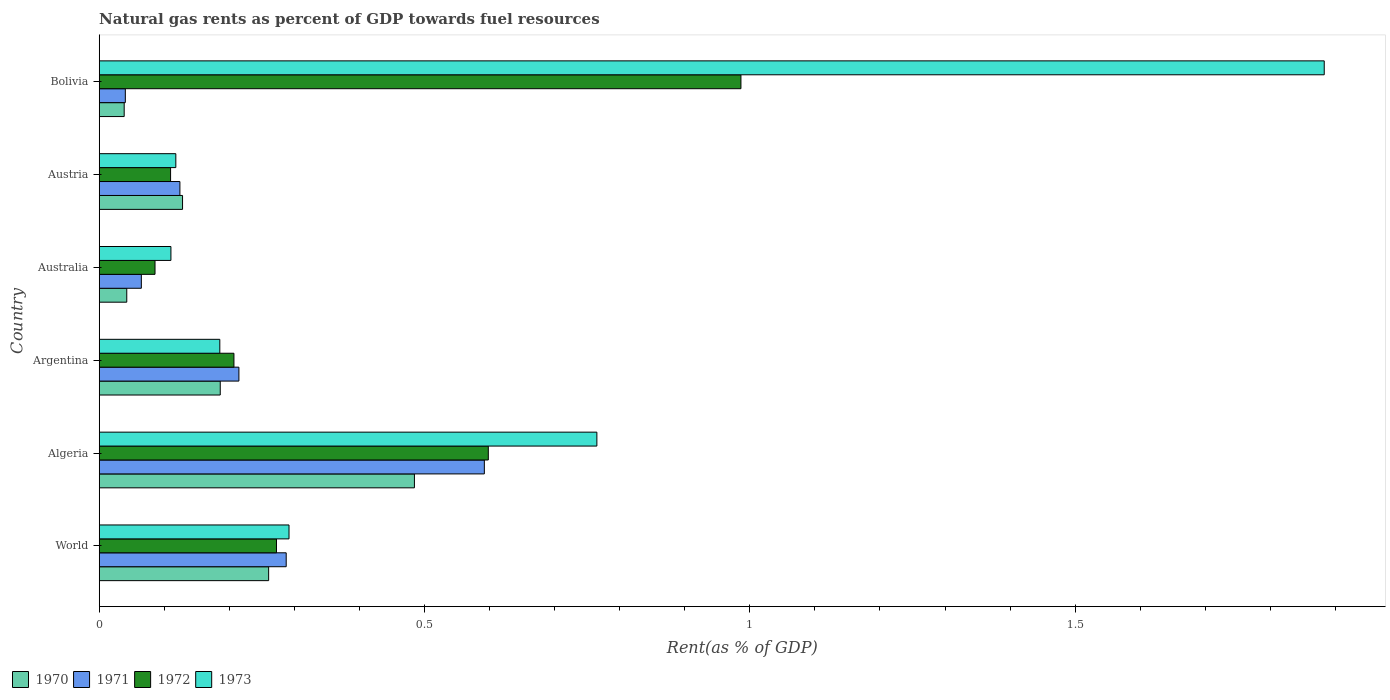Are the number of bars on each tick of the Y-axis equal?
Offer a very short reply. Yes. What is the label of the 4th group of bars from the top?
Offer a terse response. Argentina. In how many cases, is the number of bars for a given country not equal to the number of legend labels?
Make the answer very short. 0. What is the matural gas rent in 1971 in World?
Ensure brevity in your answer.  0.29. Across all countries, what is the maximum matural gas rent in 1970?
Keep it short and to the point. 0.48. Across all countries, what is the minimum matural gas rent in 1971?
Ensure brevity in your answer.  0.04. What is the total matural gas rent in 1970 in the graph?
Your answer should be very brief. 1.14. What is the difference between the matural gas rent in 1972 in Argentina and that in Austria?
Your response must be concise. 0.1. What is the difference between the matural gas rent in 1970 in Australia and the matural gas rent in 1973 in Austria?
Ensure brevity in your answer.  -0.08. What is the average matural gas rent in 1971 per country?
Keep it short and to the point. 0.22. What is the difference between the matural gas rent in 1971 and matural gas rent in 1970 in World?
Give a very brief answer. 0.03. In how many countries, is the matural gas rent in 1972 greater than 0.9 %?
Give a very brief answer. 1. What is the ratio of the matural gas rent in 1972 in Argentina to that in Bolivia?
Offer a very short reply. 0.21. Is the matural gas rent in 1970 in Argentina less than that in Austria?
Provide a succinct answer. No. What is the difference between the highest and the second highest matural gas rent in 1970?
Provide a short and direct response. 0.22. What is the difference between the highest and the lowest matural gas rent in 1971?
Provide a short and direct response. 0.55. In how many countries, is the matural gas rent in 1971 greater than the average matural gas rent in 1971 taken over all countries?
Your answer should be very brief. 2. Is the sum of the matural gas rent in 1970 in Algeria and Bolivia greater than the maximum matural gas rent in 1972 across all countries?
Offer a terse response. No. Is it the case that in every country, the sum of the matural gas rent in 1973 and matural gas rent in 1971 is greater than the sum of matural gas rent in 1972 and matural gas rent in 1970?
Provide a succinct answer. No. What does the 3rd bar from the top in World represents?
Provide a short and direct response. 1971. What does the 4th bar from the bottom in World represents?
Offer a terse response. 1973. Is it the case that in every country, the sum of the matural gas rent in 1971 and matural gas rent in 1973 is greater than the matural gas rent in 1970?
Your response must be concise. Yes. How many bars are there?
Offer a terse response. 24. What is the difference between two consecutive major ticks on the X-axis?
Offer a terse response. 0.5. Does the graph contain grids?
Ensure brevity in your answer.  No. How are the legend labels stacked?
Your response must be concise. Horizontal. What is the title of the graph?
Ensure brevity in your answer.  Natural gas rents as percent of GDP towards fuel resources. Does "1966" appear as one of the legend labels in the graph?
Your answer should be compact. No. What is the label or title of the X-axis?
Your answer should be compact. Rent(as % of GDP). What is the Rent(as % of GDP) in 1970 in World?
Ensure brevity in your answer.  0.26. What is the Rent(as % of GDP) in 1971 in World?
Provide a short and direct response. 0.29. What is the Rent(as % of GDP) in 1972 in World?
Make the answer very short. 0.27. What is the Rent(as % of GDP) in 1973 in World?
Keep it short and to the point. 0.29. What is the Rent(as % of GDP) of 1970 in Algeria?
Your answer should be compact. 0.48. What is the Rent(as % of GDP) in 1971 in Algeria?
Provide a succinct answer. 0.59. What is the Rent(as % of GDP) in 1972 in Algeria?
Keep it short and to the point. 0.6. What is the Rent(as % of GDP) in 1973 in Algeria?
Your answer should be compact. 0.76. What is the Rent(as % of GDP) in 1970 in Argentina?
Ensure brevity in your answer.  0.19. What is the Rent(as % of GDP) of 1971 in Argentina?
Give a very brief answer. 0.21. What is the Rent(as % of GDP) in 1972 in Argentina?
Make the answer very short. 0.21. What is the Rent(as % of GDP) in 1973 in Argentina?
Provide a short and direct response. 0.19. What is the Rent(as % of GDP) in 1970 in Australia?
Your response must be concise. 0.04. What is the Rent(as % of GDP) in 1971 in Australia?
Offer a terse response. 0.06. What is the Rent(as % of GDP) in 1972 in Australia?
Provide a succinct answer. 0.09. What is the Rent(as % of GDP) in 1973 in Australia?
Offer a terse response. 0.11. What is the Rent(as % of GDP) of 1970 in Austria?
Offer a very short reply. 0.13. What is the Rent(as % of GDP) in 1971 in Austria?
Provide a short and direct response. 0.12. What is the Rent(as % of GDP) of 1972 in Austria?
Make the answer very short. 0.11. What is the Rent(as % of GDP) of 1973 in Austria?
Your answer should be compact. 0.12. What is the Rent(as % of GDP) of 1970 in Bolivia?
Keep it short and to the point. 0.04. What is the Rent(as % of GDP) of 1971 in Bolivia?
Your answer should be very brief. 0.04. What is the Rent(as % of GDP) in 1972 in Bolivia?
Offer a very short reply. 0.99. What is the Rent(as % of GDP) in 1973 in Bolivia?
Offer a terse response. 1.88. Across all countries, what is the maximum Rent(as % of GDP) of 1970?
Your response must be concise. 0.48. Across all countries, what is the maximum Rent(as % of GDP) of 1971?
Your answer should be very brief. 0.59. Across all countries, what is the maximum Rent(as % of GDP) of 1972?
Your answer should be compact. 0.99. Across all countries, what is the maximum Rent(as % of GDP) in 1973?
Your answer should be compact. 1.88. Across all countries, what is the minimum Rent(as % of GDP) of 1970?
Offer a terse response. 0.04. Across all countries, what is the minimum Rent(as % of GDP) of 1971?
Give a very brief answer. 0.04. Across all countries, what is the minimum Rent(as % of GDP) of 1972?
Your response must be concise. 0.09. Across all countries, what is the minimum Rent(as % of GDP) in 1973?
Keep it short and to the point. 0.11. What is the total Rent(as % of GDP) of 1970 in the graph?
Your response must be concise. 1.14. What is the total Rent(as % of GDP) in 1971 in the graph?
Offer a terse response. 1.32. What is the total Rent(as % of GDP) of 1972 in the graph?
Offer a very short reply. 2.26. What is the total Rent(as % of GDP) of 1973 in the graph?
Make the answer very short. 3.35. What is the difference between the Rent(as % of GDP) in 1970 in World and that in Algeria?
Your response must be concise. -0.22. What is the difference between the Rent(as % of GDP) in 1971 in World and that in Algeria?
Your answer should be compact. -0.3. What is the difference between the Rent(as % of GDP) of 1972 in World and that in Algeria?
Give a very brief answer. -0.33. What is the difference between the Rent(as % of GDP) in 1973 in World and that in Algeria?
Keep it short and to the point. -0.47. What is the difference between the Rent(as % of GDP) of 1970 in World and that in Argentina?
Your response must be concise. 0.07. What is the difference between the Rent(as % of GDP) of 1971 in World and that in Argentina?
Offer a terse response. 0.07. What is the difference between the Rent(as % of GDP) of 1972 in World and that in Argentina?
Give a very brief answer. 0.07. What is the difference between the Rent(as % of GDP) of 1973 in World and that in Argentina?
Offer a terse response. 0.11. What is the difference between the Rent(as % of GDP) in 1970 in World and that in Australia?
Provide a short and direct response. 0.22. What is the difference between the Rent(as % of GDP) in 1971 in World and that in Australia?
Your answer should be compact. 0.22. What is the difference between the Rent(as % of GDP) of 1972 in World and that in Australia?
Your answer should be very brief. 0.19. What is the difference between the Rent(as % of GDP) of 1973 in World and that in Australia?
Your answer should be compact. 0.18. What is the difference between the Rent(as % of GDP) in 1970 in World and that in Austria?
Your answer should be compact. 0.13. What is the difference between the Rent(as % of GDP) in 1971 in World and that in Austria?
Your response must be concise. 0.16. What is the difference between the Rent(as % of GDP) of 1972 in World and that in Austria?
Offer a terse response. 0.16. What is the difference between the Rent(as % of GDP) of 1973 in World and that in Austria?
Provide a short and direct response. 0.17. What is the difference between the Rent(as % of GDP) of 1970 in World and that in Bolivia?
Your answer should be very brief. 0.22. What is the difference between the Rent(as % of GDP) in 1971 in World and that in Bolivia?
Provide a succinct answer. 0.25. What is the difference between the Rent(as % of GDP) in 1972 in World and that in Bolivia?
Provide a succinct answer. -0.71. What is the difference between the Rent(as % of GDP) of 1973 in World and that in Bolivia?
Give a very brief answer. -1.59. What is the difference between the Rent(as % of GDP) in 1970 in Algeria and that in Argentina?
Your response must be concise. 0.3. What is the difference between the Rent(as % of GDP) of 1971 in Algeria and that in Argentina?
Give a very brief answer. 0.38. What is the difference between the Rent(as % of GDP) in 1972 in Algeria and that in Argentina?
Give a very brief answer. 0.39. What is the difference between the Rent(as % of GDP) of 1973 in Algeria and that in Argentina?
Make the answer very short. 0.58. What is the difference between the Rent(as % of GDP) of 1970 in Algeria and that in Australia?
Make the answer very short. 0.44. What is the difference between the Rent(as % of GDP) of 1971 in Algeria and that in Australia?
Give a very brief answer. 0.53. What is the difference between the Rent(as % of GDP) of 1972 in Algeria and that in Australia?
Ensure brevity in your answer.  0.51. What is the difference between the Rent(as % of GDP) in 1973 in Algeria and that in Australia?
Offer a very short reply. 0.65. What is the difference between the Rent(as % of GDP) in 1970 in Algeria and that in Austria?
Provide a short and direct response. 0.36. What is the difference between the Rent(as % of GDP) in 1971 in Algeria and that in Austria?
Ensure brevity in your answer.  0.47. What is the difference between the Rent(as % of GDP) in 1972 in Algeria and that in Austria?
Make the answer very short. 0.49. What is the difference between the Rent(as % of GDP) of 1973 in Algeria and that in Austria?
Give a very brief answer. 0.65. What is the difference between the Rent(as % of GDP) of 1970 in Algeria and that in Bolivia?
Ensure brevity in your answer.  0.45. What is the difference between the Rent(as % of GDP) of 1971 in Algeria and that in Bolivia?
Your answer should be very brief. 0.55. What is the difference between the Rent(as % of GDP) in 1972 in Algeria and that in Bolivia?
Keep it short and to the point. -0.39. What is the difference between the Rent(as % of GDP) of 1973 in Algeria and that in Bolivia?
Provide a succinct answer. -1.12. What is the difference between the Rent(as % of GDP) in 1970 in Argentina and that in Australia?
Your answer should be compact. 0.14. What is the difference between the Rent(as % of GDP) of 1971 in Argentina and that in Australia?
Your answer should be compact. 0.15. What is the difference between the Rent(as % of GDP) of 1972 in Argentina and that in Australia?
Provide a short and direct response. 0.12. What is the difference between the Rent(as % of GDP) of 1973 in Argentina and that in Australia?
Offer a very short reply. 0.08. What is the difference between the Rent(as % of GDP) in 1970 in Argentina and that in Austria?
Provide a short and direct response. 0.06. What is the difference between the Rent(as % of GDP) in 1971 in Argentina and that in Austria?
Your answer should be very brief. 0.09. What is the difference between the Rent(as % of GDP) of 1972 in Argentina and that in Austria?
Offer a terse response. 0.1. What is the difference between the Rent(as % of GDP) of 1973 in Argentina and that in Austria?
Offer a terse response. 0.07. What is the difference between the Rent(as % of GDP) in 1970 in Argentina and that in Bolivia?
Offer a terse response. 0.15. What is the difference between the Rent(as % of GDP) in 1971 in Argentina and that in Bolivia?
Ensure brevity in your answer.  0.17. What is the difference between the Rent(as % of GDP) of 1972 in Argentina and that in Bolivia?
Give a very brief answer. -0.78. What is the difference between the Rent(as % of GDP) of 1973 in Argentina and that in Bolivia?
Offer a terse response. -1.7. What is the difference between the Rent(as % of GDP) of 1970 in Australia and that in Austria?
Your answer should be very brief. -0.09. What is the difference between the Rent(as % of GDP) in 1971 in Australia and that in Austria?
Keep it short and to the point. -0.06. What is the difference between the Rent(as % of GDP) in 1972 in Australia and that in Austria?
Keep it short and to the point. -0.02. What is the difference between the Rent(as % of GDP) in 1973 in Australia and that in Austria?
Keep it short and to the point. -0.01. What is the difference between the Rent(as % of GDP) in 1970 in Australia and that in Bolivia?
Offer a terse response. 0. What is the difference between the Rent(as % of GDP) in 1971 in Australia and that in Bolivia?
Provide a short and direct response. 0.02. What is the difference between the Rent(as % of GDP) of 1972 in Australia and that in Bolivia?
Your answer should be very brief. -0.9. What is the difference between the Rent(as % of GDP) of 1973 in Australia and that in Bolivia?
Your response must be concise. -1.77. What is the difference between the Rent(as % of GDP) of 1970 in Austria and that in Bolivia?
Your answer should be compact. 0.09. What is the difference between the Rent(as % of GDP) in 1971 in Austria and that in Bolivia?
Your response must be concise. 0.08. What is the difference between the Rent(as % of GDP) in 1972 in Austria and that in Bolivia?
Offer a terse response. -0.88. What is the difference between the Rent(as % of GDP) in 1973 in Austria and that in Bolivia?
Keep it short and to the point. -1.77. What is the difference between the Rent(as % of GDP) of 1970 in World and the Rent(as % of GDP) of 1971 in Algeria?
Provide a short and direct response. -0.33. What is the difference between the Rent(as % of GDP) in 1970 in World and the Rent(as % of GDP) in 1972 in Algeria?
Offer a very short reply. -0.34. What is the difference between the Rent(as % of GDP) in 1970 in World and the Rent(as % of GDP) in 1973 in Algeria?
Keep it short and to the point. -0.5. What is the difference between the Rent(as % of GDP) in 1971 in World and the Rent(as % of GDP) in 1972 in Algeria?
Provide a short and direct response. -0.31. What is the difference between the Rent(as % of GDP) of 1971 in World and the Rent(as % of GDP) of 1973 in Algeria?
Provide a short and direct response. -0.48. What is the difference between the Rent(as % of GDP) in 1972 in World and the Rent(as % of GDP) in 1973 in Algeria?
Your answer should be very brief. -0.49. What is the difference between the Rent(as % of GDP) in 1970 in World and the Rent(as % of GDP) in 1971 in Argentina?
Your answer should be compact. 0.05. What is the difference between the Rent(as % of GDP) of 1970 in World and the Rent(as % of GDP) of 1972 in Argentina?
Keep it short and to the point. 0.05. What is the difference between the Rent(as % of GDP) in 1970 in World and the Rent(as % of GDP) in 1973 in Argentina?
Your answer should be compact. 0.07. What is the difference between the Rent(as % of GDP) in 1971 in World and the Rent(as % of GDP) in 1972 in Argentina?
Your answer should be compact. 0.08. What is the difference between the Rent(as % of GDP) in 1971 in World and the Rent(as % of GDP) in 1973 in Argentina?
Provide a succinct answer. 0.1. What is the difference between the Rent(as % of GDP) of 1972 in World and the Rent(as % of GDP) of 1973 in Argentina?
Your response must be concise. 0.09. What is the difference between the Rent(as % of GDP) in 1970 in World and the Rent(as % of GDP) in 1971 in Australia?
Give a very brief answer. 0.2. What is the difference between the Rent(as % of GDP) in 1970 in World and the Rent(as % of GDP) in 1972 in Australia?
Provide a succinct answer. 0.17. What is the difference between the Rent(as % of GDP) in 1970 in World and the Rent(as % of GDP) in 1973 in Australia?
Your answer should be compact. 0.15. What is the difference between the Rent(as % of GDP) of 1971 in World and the Rent(as % of GDP) of 1972 in Australia?
Provide a succinct answer. 0.2. What is the difference between the Rent(as % of GDP) in 1971 in World and the Rent(as % of GDP) in 1973 in Australia?
Offer a terse response. 0.18. What is the difference between the Rent(as % of GDP) of 1972 in World and the Rent(as % of GDP) of 1973 in Australia?
Give a very brief answer. 0.16. What is the difference between the Rent(as % of GDP) of 1970 in World and the Rent(as % of GDP) of 1971 in Austria?
Your answer should be very brief. 0.14. What is the difference between the Rent(as % of GDP) in 1970 in World and the Rent(as % of GDP) in 1972 in Austria?
Make the answer very short. 0.15. What is the difference between the Rent(as % of GDP) of 1970 in World and the Rent(as % of GDP) of 1973 in Austria?
Offer a terse response. 0.14. What is the difference between the Rent(as % of GDP) in 1971 in World and the Rent(as % of GDP) in 1972 in Austria?
Keep it short and to the point. 0.18. What is the difference between the Rent(as % of GDP) of 1971 in World and the Rent(as % of GDP) of 1973 in Austria?
Ensure brevity in your answer.  0.17. What is the difference between the Rent(as % of GDP) of 1972 in World and the Rent(as % of GDP) of 1973 in Austria?
Keep it short and to the point. 0.15. What is the difference between the Rent(as % of GDP) of 1970 in World and the Rent(as % of GDP) of 1971 in Bolivia?
Your answer should be compact. 0.22. What is the difference between the Rent(as % of GDP) in 1970 in World and the Rent(as % of GDP) in 1972 in Bolivia?
Offer a terse response. -0.73. What is the difference between the Rent(as % of GDP) in 1970 in World and the Rent(as % of GDP) in 1973 in Bolivia?
Your response must be concise. -1.62. What is the difference between the Rent(as % of GDP) of 1971 in World and the Rent(as % of GDP) of 1972 in Bolivia?
Keep it short and to the point. -0.7. What is the difference between the Rent(as % of GDP) of 1971 in World and the Rent(as % of GDP) of 1973 in Bolivia?
Keep it short and to the point. -1.6. What is the difference between the Rent(as % of GDP) of 1972 in World and the Rent(as % of GDP) of 1973 in Bolivia?
Keep it short and to the point. -1.61. What is the difference between the Rent(as % of GDP) in 1970 in Algeria and the Rent(as % of GDP) in 1971 in Argentina?
Give a very brief answer. 0.27. What is the difference between the Rent(as % of GDP) in 1970 in Algeria and the Rent(as % of GDP) in 1972 in Argentina?
Make the answer very short. 0.28. What is the difference between the Rent(as % of GDP) of 1970 in Algeria and the Rent(as % of GDP) of 1973 in Argentina?
Your answer should be compact. 0.3. What is the difference between the Rent(as % of GDP) of 1971 in Algeria and the Rent(as % of GDP) of 1972 in Argentina?
Make the answer very short. 0.38. What is the difference between the Rent(as % of GDP) of 1971 in Algeria and the Rent(as % of GDP) of 1973 in Argentina?
Make the answer very short. 0.41. What is the difference between the Rent(as % of GDP) of 1972 in Algeria and the Rent(as % of GDP) of 1973 in Argentina?
Offer a terse response. 0.41. What is the difference between the Rent(as % of GDP) of 1970 in Algeria and the Rent(as % of GDP) of 1971 in Australia?
Give a very brief answer. 0.42. What is the difference between the Rent(as % of GDP) in 1970 in Algeria and the Rent(as % of GDP) in 1972 in Australia?
Offer a very short reply. 0.4. What is the difference between the Rent(as % of GDP) in 1970 in Algeria and the Rent(as % of GDP) in 1973 in Australia?
Keep it short and to the point. 0.37. What is the difference between the Rent(as % of GDP) of 1971 in Algeria and the Rent(as % of GDP) of 1972 in Australia?
Offer a terse response. 0.51. What is the difference between the Rent(as % of GDP) in 1971 in Algeria and the Rent(as % of GDP) in 1973 in Australia?
Your answer should be very brief. 0.48. What is the difference between the Rent(as % of GDP) of 1972 in Algeria and the Rent(as % of GDP) of 1973 in Australia?
Keep it short and to the point. 0.49. What is the difference between the Rent(as % of GDP) in 1970 in Algeria and the Rent(as % of GDP) in 1971 in Austria?
Ensure brevity in your answer.  0.36. What is the difference between the Rent(as % of GDP) in 1970 in Algeria and the Rent(as % of GDP) in 1972 in Austria?
Ensure brevity in your answer.  0.37. What is the difference between the Rent(as % of GDP) of 1970 in Algeria and the Rent(as % of GDP) of 1973 in Austria?
Offer a very short reply. 0.37. What is the difference between the Rent(as % of GDP) in 1971 in Algeria and the Rent(as % of GDP) in 1972 in Austria?
Give a very brief answer. 0.48. What is the difference between the Rent(as % of GDP) in 1971 in Algeria and the Rent(as % of GDP) in 1973 in Austria?
Offer a terse response. 0.47. What is the difference between the Rent(as % of GDP) in 1972 in Algeria and the Rent(as % of GDP) in 1973 in Austria?
Your answer should be very brief. 0.48. What is the difference between the Rent(as % of GDP) of 1970 in Algeria and the Rent(as % of GDP) of 1971 in Bolivia?
Offer a very short reply. 0.44. What is the difference between the Rent(as % of GDP) of 1970 in Algeria and the Rent(as % of GDP) of 1972 in Bolivia?
Give a very brief answer. -0.5. What is the difference between the Rent(as % of GDP) of 1970 in Algeria and the Rent(as % of GDP) of 1973 in Bolivia?
Your answer should be very brief. -1.4. What is the difference between the Rent(as % of GDP) in 1971 in Algeria and the Rent(as % of GDP) in 1972 in Bolivia?
Keep it short and to the point. -0.39. What is the difference between the Rent(as % of GDP) of 1971 in Algeria and the Rent(as % of GDP) of 1973 in Bolivia?
Make the answer very short. -1.29. What is the difference between the Rent(as % of GDP) in 1972 in Algeria and the Rent(as % of GDP) in 1973 in Bolivia?
Provide a succinct answer. -1.28. What is the difference between the Rent(as % of GDP) in 1970 in Argentina and the Rent(as % of GDP) in 1971 in Australia?
Ensure brevity in your answer.  0.12. What is the difference between the Rent(as % of GDP) in 1970 in Argentina and the Rent(as % of GDP) in 1972 in Australia?
Your answer should be very brief. 0.1. What is the difference between the Rent(as % of GDP) in 1970 in Argentina and the Rent(as % of GDP) in 1973 in Australia?
Offer a terse response. 0.08. What is the difference between the Rent(as % of GDP) of 1971 in Argentina and the Rent(as % of GDP) of 1972 in Australia?
Your answer should be compact. 0.13. What is the difference between the Rent(as % of GDP) of 1971 in Argentina and the Rent(as % of GDP) of 1973 in Australia?
Make the answer very short. 0.1. What is the difference between the Rent(as % of GDP) of 1972 in Argentina and the Rent(as % of GDP) of 1973 in Australia?
Give a very brief answer. 0.1. What is the difference between the Rent(as % of GDP) in 1970 in Argentina and the Rent(as % of GDP) in 1971 in Austria?
Your answer should be compact. 0.06. What is the difference between the Rent(as % of GDP) of 1970 in Argentina and the Rent(as % of GDP) of 1972 in Austria?
Keep it short and to the point. 0.08. What is the difference between the Rent(as % of GDP) of 1970 in Argentina and the Rent(as % of GDP) of 1973 in Austria?
Keep it short and to the point. 0.07. What is the difference between the Rent(as % of GDP) in 1971 in Argentina and the Rent(as % of GDP) in 1972 in Austria?
Keep it short and to the point. 0.1. What is the difference between the Rent(as % of GDP) of 1971 in Argentina and the Rent(as % of GDP) of 1973 in Austria?
Offer a very short reply. 0.1. What is the difference between the Rent(as % of GDP) in 1972 in Argentina and the Rent(as % of GDP) in 1973 in Austria?
Your response must be concise. 0.09. What is the difference between the Rent(as % of GDP) in 1970 in Argentina and the Rent(as % of GDP) in 1971 in Bolivia?
Offer a very short reply. 0.15. What is the difference between the Rent(as % of GDP) in 1970 in Argentina and the Rent(as % of GDP) in 1972 in Bolivia?
Your response must be concise. -0.8. What is the difference between the Rent(as % of GDP) in 1970 in Argentina and the Rent(as % of GDP) in 1973 in Bolivia?
Give a very brief answer. -1.7. What is the difference between the Rent(as % of GDP) in 1971 in Argentina and the Rent(as % of GDP) in 1972 in Bolivia?
Your response must be concise. -0.77. What is the difference between the Rent(as % of GDP) in 1971 in Argentina and the Rent(as % of GDP) in 1973 in Bolivia?
Offer a terse response. -1.67. What is the difference between the Rent(as % of GDP) of 1972 in Argentina and the Rent(as % of GDP) of 1973 in Bolivia?
Offer a terse response. -1.68. What is the difference between the Rent(as % of GDP) in 1970 in Australia and the Rent(as % of GDP) in 1971 in Austria?
Provide a short and direct response. -0.08. What is the difference between the Rent(as % of GDP) in 1970 in Australia and the Rent(as % of GDP) in 1972 in Austria?
Ensure brevity in your answer.  -0.07. What is the difference between the Rent(as % of GDP) of 1970 in Australia and the Rent(as % of GDP) of 1973 in Austria?
Ensure brevity in your answer.  -0.08. What is the difference between the Rent(as % of GDP) of 1971 in Australia and the Rent(as % of GDP) of 1972 in Austria?
Your response must be concise. -0.04. What is the difference between the Rent(as % of GDP) of 1971 in Australia and the Rent(as % of GDP) of 1973 in Austria?
Offer a terse response. -0.05. What is the difference between the Rent(as % of GDP) in 1972 in Australia and the Rent(as % of GDP) in 1973 in Austria?
Give a very brief answer. -0.03. What is the difference between the Rent(as % of GDP) of 1970 in Australia and the Rent(as % of GDP) of 1971 in Bolivia?
Your response must be concise. 0. What is the difference between the Rent(as % of GDP) of 1970 in Australia and the Rent(as % of GDP) of 1972 in Bolivia?
Your answer should be very brief. -0.94. What is the difference between the Rent(as % of GDP) of 1970 in Australia and the Rent(as % of GDP) of 1973 in Bolivia?
Your response must be concise. -1.84. What is the difference between the Rent(as % of GDP) of 1971 in Australia and the Rent(as % of GDP) of 1972 in Bolivia?
Offer a very short reply. -0.92. What is the difference between the Rent(as % of GDP) of 1971 in Australia and the Rent(as % of GDP) of 1973 in Bolivia?
Provide a short and direct response. -1.82. What is the difference between the Rent(as % of GDP) in 1972 in Australia and the Rent(as % of GDP) in 1973 in Bolivia?
Give a very brief answer. -1.8. What is the difference between the Rent(as % of GDP) in 1970 in Austria and the Rent(as % of GDP) in 1971 in Bolivia?
Keep it short and to the point. 0.09. What is the difference between the Rent(as % of GDP) in 1970 in Austria and the Rent(as % of GDP) in 1972 in Bolivia?
Ensure brevity in your answer.  -0.86. What is the difference between the Rent(as % of GDP) of 1970 in Austria and the Rent(as % of GDP) of 1973 in Bolivia?
Offer a terse response. -1.75. What is the difference between the Rent(as % of GDP) in 1971 in Austria and the Rent(as % of GDP) in 1972 in Bolivia?
Your response must be concise. -0.86. What is the difference between the Rent(as % of GDP) in 1971 in Austria and the Rent(as % of GDP) in 1973 in Bolivia?
Provide a short and direct response. -1.76. What is the difference between the Rent(as % of GDP) of 1972 in Austria and the Rent(as % of GDP) of 1973 in Bolivia?
Ensure brevity in your answer.  -1.77. What is the average Rent(as % of GDP) of 1970 per country?
Provide a short and direct response. 0.19. What is the average Rent(as % of GDP) in 1971 per country?
Make the answer very short. 0.22. What is the average Rent(as % of GDP) in 1972 per country?
Offer a very short reply. 0.38. What is the average Rent(as % of GDP) of 1973 per country?
Ensure brevity in your answer.  0.56. What is the difference between the Rent(as % of GDP) in 1970 and Rent(as % of GDP) in 1971 in World?
Ensure brevity in your answer.  -0.03. What is the difference between the Rent(as % of GDP) of 1970 and Rent(as % of GDP) of 1972 in World?
Your answer should be compact. -0.01. What is the difference between the Rent(as % of GDP) in 1970 and Rent(as % of GDP) in 1973 in World?
Give a very brief answer. -0.03. What is the difference between the Rent(as % of GDP) of 1971 and Rent(as % of GDP) of 1972 in World?
Offer a very short reply. 0.01. What is the difference between the Rent(as % of GDP) in 1971 and Rent(as % of GDP) in 1973 in World?
Your answer should be compact. -0. What is the difference between the Rent(as % of GDP) of 1972 and Rent(as % of GDP) of 1973 in World?
Provide a succinct answer. -0.02. What is the difference between the Rent(as % of GDP) of 1970 and Rent(as % of GDP) of 1971 in Algeria?
Offer a terse response. -0.11. What is the difference between the Rent(as % of GDP) of 1970 and Rent(as % of GDP) of 1972 in Algeria?
Your answer should be compact. -0.11. What is the difference between the Rent(as % of GDP) in 1970 and Rent(as % of GDP) in 1973 in Algeria?
Offer a terse response. -0.28. What is the difference between the Rent(as % of GDP) of 1971 and Rent(as % of GDP) of 1972 in Algeria?
Offer a terse response. -0.01. What is the difference between the Rent(as % of GDP) of 1971 and Rent(as % of GDP) of 1973 in Algeria?
Your response must be concise. -0.17. What is the difference between the Rent(as % of GDP) in 1972 and Rent(as % of GDP) in 1973 in Algeria?
Your answer should be compact. -0.17. What is the difference between the Rent(as % of GDP) in 1970 and Rent(as % of GDP) in 1971 in Argentina?
Provide a succinct answer. -0.03. What is the difference between the Rent(as % of GDP) of 1970 and Rent(as % of GDP) of 1972 in Argentina?
Make the answer very short. -0.02. What is the difference between the Rent(as % of GDP) in 1970 and Rent(as % of GDP) in 1973 in Argentina?
Your response must be concise. 0. What is the difference between the Rent(as % of GDP) in 1971 and Rent(as % of GDP) in 1972 in Argentina?
Provide a short and direct response. 0.01. What is the difference between the Rent(as % of GDP) in 1971 and Rent(as % of GDP) in 1973 in Argentina?
Provide a short and direct response. 0.03. What is the difference between the Rent(as % of GDP) of 1972 and Rent(as % of GDP) of 1973 in Argentina?
Ensure brevity in your answer.  0.02. What is the difference between the Rent(as % of GDP) of 1970 and Rent(as % of GDP) of 1971 in Australia?
Ensure brevity in your answer.  -0.02. What is the difference between the Rent(as % of GDP) in 1970 and Rent(as % of GDP) in 1972 in Australia?
Offer a terse response. -0.04. What is the difference between the Rent(as % of GDP) of 1970 and Rent(as % of GDP) of 1973 in Australia?
Your answer should be compact. -0.07. What is the difference between the Rent(as % of GDP) of 1971 and Rent(as % of GDP) of 1972 in Australia?
Offer a terse response. -0.02. What is the difference between the Rent(as % of GDP) of 1971 and Rent(as % of GDP) of 1973 in Australia?
Give a very brief answer. -0.05. What is the difference between the Rent(as % of GDP) in 1972 and Rent(as % of GDP) in 1973 in Australia?
Offer a very short reply. -0.02. What is the difference between the Rent(as % of GDP) of 1970 and Rent(as % of GDP) of 1971 in Austria?
Offer a very short reply. 0. What is the difference between the Rent(as % of GDP) of 1970 and Rent(as % of GDP) of 1972 in Austria?
Keep it short and to the point. 0.02. What is the difference between the Rent(as % of GDP) in 1970 and Rent(as % of GDP) in 1973 in Austria?
Your answer should be compact. 0.01. What is the difference between the Rent(as % of GDP) in 1971 and Rent(as % of GDP) in 1972 in Austria?
Offer a terse response. 0.01. What is the difference between the Rent(as % of GDP) in 1971 and Rent(as % of GDP) in 1973 in Austria?
Give a very brief answer. 0.01. What is the difference between the Rent(as % of GDP) in 1972 and Rent(as % of GDP) in 1973 in Austria?
Provide a succinct answer. -0.01. What is the difference between the Rent(as % of GDP) in 1970 and Rent(as % of GDP) in 1971 in Bolivia?
Give a very brief answer. -0. What is the difference between the Rent(as % of GDP) of 1970 and Rent(as % of GDP) of 1972 in Bolivia?
Give a very brief answer. -0.95. What is the difference between the Rent(as % of GDP) of 1970 and Rent(as % of GDP) of 1973 in Bolivia?
Provide a short and direct response. -1.84. What is the difference between the Rent(as % of GDP) in 1971 and Rent(as % of GDP) in 1972 in Bolivia?
Your answer should be very brief. -0.95. What is the difference between the Rent(as % of GDP) in 1971 and Rent(as % of GDP) in 1973 in Bolivia?
Your response must be concise. -1.84. What is the difference between the Rent(as % of GDP) in 1972 and Rent(as % of GDP) in 1973 in Bolivia?
Offer a terse response. -0.9. What is the ratio of the Rent(as % of GDP) in 1970 in World to that in Algeria?
Your response must be concise. 0.54. What is the ratio of the Rent(as % of GDP) in 1971 in World to that in Algeria?
Make the answer very short. 0.49. What is the ratio of the Rent(as % of GDP) in 1972 in World to that in Algeria?
Ensure brevity in your answer.  0.46. What is the ratio of the Rent(as % of GDP) of 1973 in World to that in Algeria?
Your answer should be very brief. 0.38. What is the ratio of the Rent(as % of GDP) in 1970 in World to that in Argentina?
Give a very brief answer. 1.4. What is the ratio of the Rent(as % of GDP) of 1971 in World to that in Argentina?
Your answer should be compact. 1.34. What is the ratio of the Rent(as % of GDP) in 1972 in World to that in Argentina?
Provide a succinct answer. 1.32. What is the ratio of the Rent(as % of GDP) of 1973 in World to that in Argentina?
Your response must be concise. 1.57. What is the ratio of the Rent(as % of GDP) of 1970 in World to that in Australia?
Your answer should be compact. 6.15. What is the ratio of the Rent(as % of GDP) of 1971 in World to that in Australia?
Your answer should be very brief. 4.44. What is the ratio of the Rent(as % of GDP) in 1972 in World to that in Australia?
Give a very brief answer. 3.18. What is the ratio of the Rent(as % of GDP) of 1973 in World to that in Australia?
Your answer should be very brief. 2.65. What is the ratio of the Rent(as % of GDP) of 1970 in World to that in Austria?
Provide a succinct answer. 2.03. What is the ratio of the Rent(as % of GDP) of 1971 in World to that in Austria?
Make the answer very short. 2.32. What is the ratio of the Rent(as % of GDP) in 1972 in World to that in Austria?
Give a very brief answer. 2.48. What is the ratio of the Rent(as % of GDP) of 1973 in World to that in Austria?
Your answer should be very brief. 2.48. What is the ratio of the Rent(as % of GDP) in 1970 in World to that in Bolivia?
Make the answer very short. 6.78. What is the ratio of the Rent(as % of GDP) in 1971 in World to that in Bolivia?
Your answer should be compact. 7.16. What is the ratio of the Rent(as % of GDP) of 1972 in World to that in Bolivia?
Provide a succinct answer. 0.28. What is the ratio of the Rent(as % of GDP) in 1973 in World to that in Bolivia?
Provide a succinct answer. 0.15. What is the ratio of the Rent(as % of GDP) in 1970 in Algeria to that in Argentina?
Your answer should be very brief. 2.6. What is the ratio of the Rent(as % of GDP) of 1971 in Algeria to that in Argentina?
Your answer should be very brief. 2.76. What is the ratio of the Rent(as % of GDP) in 1972 in Algeria to that in Argentina?
Keep it short and to the point. 2.89. What is the ratio of the Rent(as % of GDP) of 1973 in Algeria to that in Argentina?
Give a very brief answer. 4.13. What is the ratio of the Rent(as % of GDP) of 1970 in Algeria to that in Australia?
Offer a terse response. 11.44. What is the ratio of the Rent(as % of GDP) in 1971 in Algeria to that in Australia?
Provide a short and direct response. 9.14. What is the ratio of the Rent(as % of GDP) of 1972 in Algeria to that in Australia?
Provide a succinct answer. 6.97. What is the ratio of the Rent(as % of GDP) of 1973 in Algeria to that in Australia?
Your answer should be very brief. 6.94. What is the ratio of the Rent(as % of GDP) of 1970 in Algeria to that in Austria?
Give a very brief answer. 3.78. What is the ratio of the Rent(as % of GDP) in 1971 in Algeria to that in Austria?
Offer a very short reply. 4.77. What is the ratio of the Rent(as % of GDP) in 1972 in Algeria to that in Austria?
Ensure brevity in your answer.  5.45. What is the ratio of the Rent(as % of GDP) of 1973 in Algeria to that in Austria?
Make the answer very short. 6.5. What is the ratio of the Rent(as % of GDP) of 1970 in Algeria to that in Bolivia?
Provide a short and direct response. 12.62. What is the ratio of the Rent(as % of GDP) in 1971 in Algeria to that in Bolivia?
Ensure brevity in your answer.  14.75. What is the ratio of the Rent(as % of GDP) of 1972 in Algeria to that in Bolivia?
Offer a terse response. 0.61. What is the ratio of the Rent(as % of GDP) of 1973 in Algeria to that in Bolivia?
Give a very brief answer. 0.41. What is the ratio of the Rent(as % of GDP) of 1970 in Argentina to that in Australia?
Your answer should be very brief. 4.39. What is the ratio of the Rent(as % of GDP) in 1971 in Argentina to that in Australia?
Make the answer very short. 3.32. What is the ratio of the Rent(as % of GDP) of 1972 in Argentina to that in Australia?
Give a very brief answer. 2.41. What is the ratio of the Rent(as % of GDP) in 1973 in Argentina to that in Australia?
Provide a succinct answer. 1.68. What is the ratio of the Rent(as % of GDP) of 1970 in Argentina to that in Austria?
Your answer should be compact. 1.45. What is the ratio of the Rent(as % of GDP) in 1971 in Argentina to that in Austria?
Give a very brief answer. 1.73. What is the ratio of the Rent(as % of GDP) of 1972 in Argentina to that in Austria?
Your answer should be very brief. 1.89. What is the ratio of the Rent(as % of GDP) of 1973 in Argentina to that in Austria?
Your answer should be very brief. 1.57. What is the ratio of the Rent(as % of GDP) in 1970 in Argentina to that in Bolivia?
Offer a very short reply. 4.85. What is the ratio of the Rent(as % of GDP) of 1971 in Argentina to that in Bolivia?
Make the answer very short. 5.35. What is the ratio of the Rent(as % of GDP) of 1972 in Argentina to that in Bolivia?
Give a very brief answer. 0.21. What is the ratio of the Rent(as % of GDP) of 1973 in Argentina to that in Bolivia?
Make the answer very short. 0.1. What is the ratio of the Rent(as % of GDP) in 1970 in Australia to that in Austria?
Keep it short and to the point. 0.33. What is the ratio of the Rent(as % of GDP) in 1971 in Australia to that in Austria?
Give a very brief answer. 0.52. What is the ratio of the Rent(as % of GDP) in 1972 in Australia to that in Austria?
Ensure brevity in your answer.  0.78. What is the ratio of the Rent(as % of GDP) in 1973 in Australia to that in Austria?
Give a very brief answer. 0.94. What is the ratio of the Rent(as % of GDP) of 1970 in Australia to that in Bolivia?
Make the answer very short. 1.1. What is the ratio of the Rent(as % of GDP) in 1971 in Australia to that in Bolivia?
Give a very brief answer. 1.61. What is the ratio of the Rent(as % of GDP) in 1972 in Australia to that in Bolivia?
Your answer should be very brief. 0.09. What is the ratio of the Rent(as % of GDP) of 1973 in Australia to that in Bolivia?
Your answer should be compact. 0.06. What is the ratio of the Rent(as % of GDP) of 1970 in Austria to that in Bolivia?
Offer a terse response. 3.34. What is the ratio of the Rent(as % of GDP) in 1971 in Austria to that in Bolivia?
Give a very brief answer. 3.09. What is the ratio of the Rent(as % of GDP) of 1972 in Austria to that in Bolivia?
Offer a very short reply. 0.11. What is the ratio of the Rent(as % of GDP) of 1973 in Austria to that in Bolivia?
Keep it short and to the point. 0.06. What is the difference between the highest and the second highest Rent(as % of GDP) in 1970?
Give a very brief answer. 0.22. What is the difference between the highest and the second highest Rent(as % of GDP) of 1971?
Offer a terse response. 0.3. What is the difference between the highest and the second highest Rent(as % of GDP) in 1972?
Your answer should be compact. 0.39. What is the difference between the highest and the second highest Rent(as % of GDP) of 1973?
Ensure brevity in your answer.  1.12. What is the difference between the highest and the lowest Rent(as % of GDP) of 1970?
Give a very brief answer. 0.45. What is the difference between the highest and the lowest Rent(as % of GDP) in 1971?
Ensure brevity in your answer.  0.55. What is the difference between the highest and the lowest Rent(as % of GDP) of 1972?
Ensure brevity in your answer.  0.9. What is the difference between the highest and the lowest Rent(as % of GDP) of 1973?
Give a very brief answer. 1.77. 